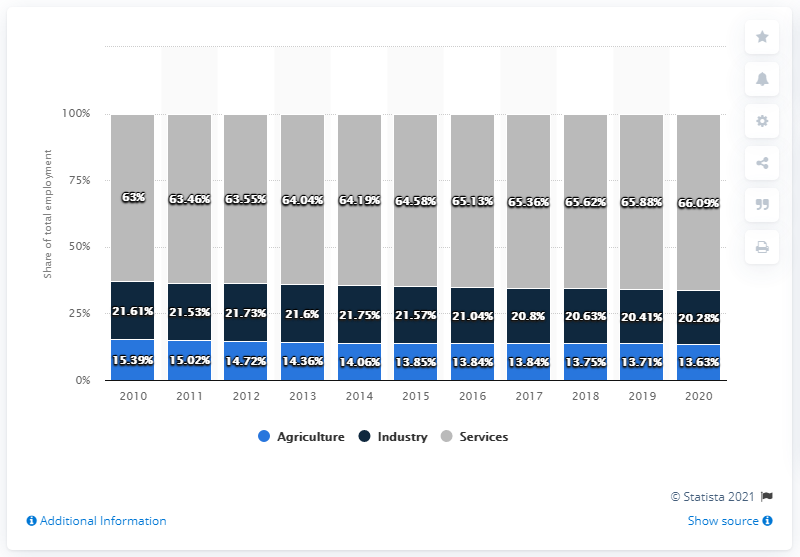Give some essential details in this illustration. In 2020, the percentage of services employment was the highest out of all the years. In 2020, the level of employment between agriculture and industry was at its lowest point. 